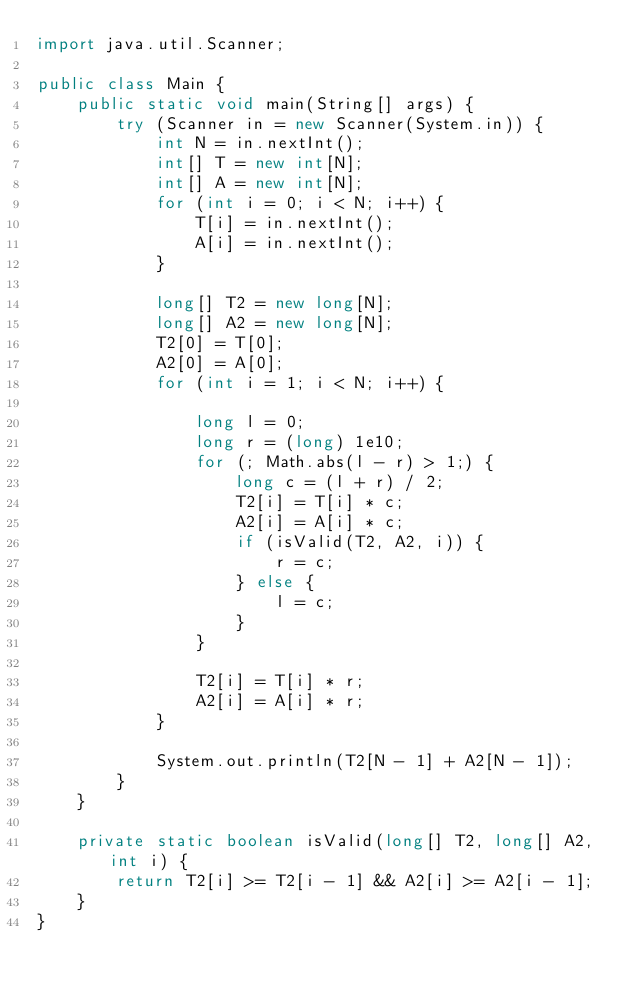<code> <loc_0><loc_0><loc_500><loc_500><_Java_>import java.util.Scanner;

public class Main {
    public static void main(String[] args) {
        try (Scanner in = new Scanner(System.in)) {
            int N = in.nextInt();
            int[] T = new int[N];
            int[] A = new int[N];
            for (int i = 0; i < N; i++) {
                T[i] = in.nextInt();
                A[i] = in.nextInt();
            }

            long[] T2 = new long[N];
            long[] A2 = new long[N];
            T2[0] = T[0];
            A2[0] = A[0];
            for (int i = 1; i < N; i++) {

                long l = 0;
                long r = (long) 1e10;
                for (; Math.abs(l - r) > 1;) {
                    long c = (l + r) / 2;
                    T2[i] = T[i] * c;
                    A2[i] = A[i] * c;
                    if (isValid(T2, A2, i)) {
                        r = c;
                    } else {
                        l = c;
                    }
                }

                T2[i] = T[i] * r;
                A2[i] = A[i] * r;
            }

            System.out.println(T2[N - 1] + A2[N - 1]);
        }
    }

    private static boolean isValid(long[] T2, long[] A2, int i) {
        return T2[i] >= T2[i - 1] && A2[i] >= A2[i - 1];
    }
}
</code> 